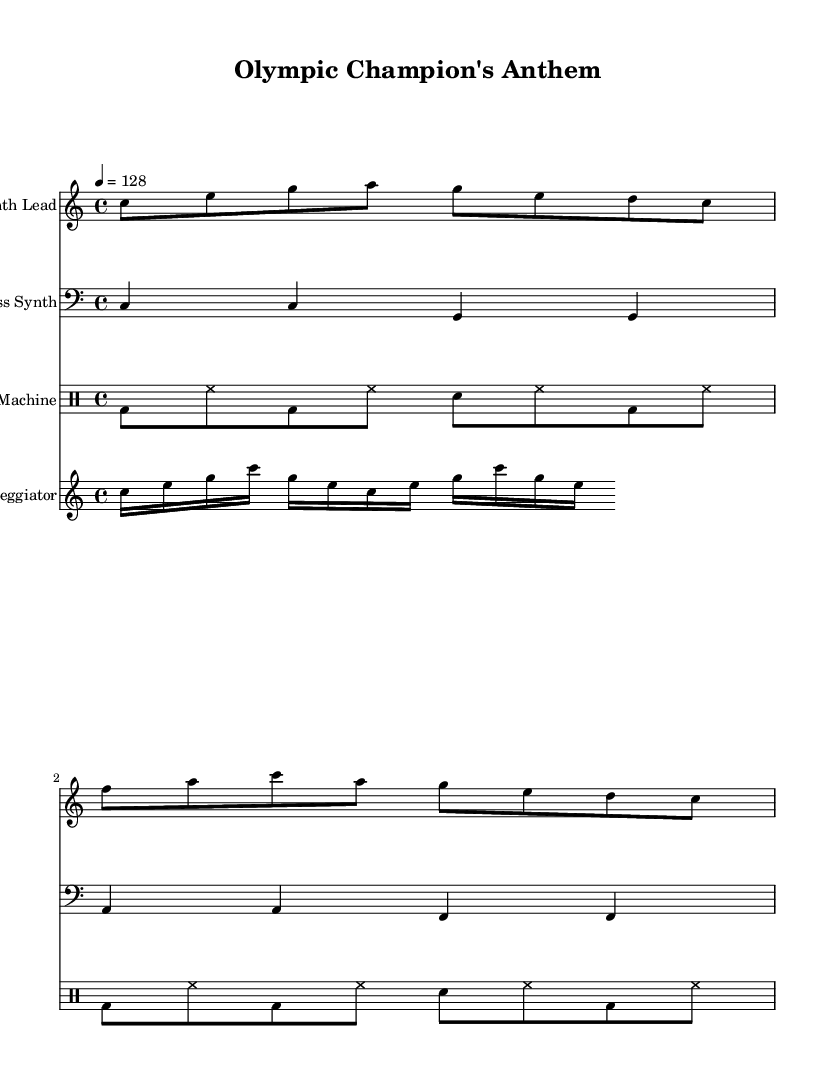What is the key signature of this music? The key signature is C major, which has no sharps or flats.
Answer: C major What is the time signature? The time signature shown in the music is 4/4, indicating four beats per measure.
Answer: 4/4 What is the tempo marking of this piece? The tempo marking indicates a tempo of 128 beats per minute as specified in the score.
Answer: 128 How many measures are there in the Synth Lead part? The Synth Lead has a total of 4 measures as counted from the notation shown.
Answer: 4 What type of music is this composition classified as? This composition is categorized as Dance music, notably upbeat electronic dance music designed for motivation.
Answer: Dance What instruments are featured in the score? The score features a Synth Lead, Bass Synth, Drum Machine, and Arpeggiator.
Answer: Synth Lead, Bass Synth, Drum Machine, Arpeggiator How many different rhythmic elements are present in the Drum Machine part? The Drum Machine part contains two main rhythmic elements: bass drum (bd) and snare (sn), along with hi-hat (hh) for consistent rhythm.
Answer: Three 